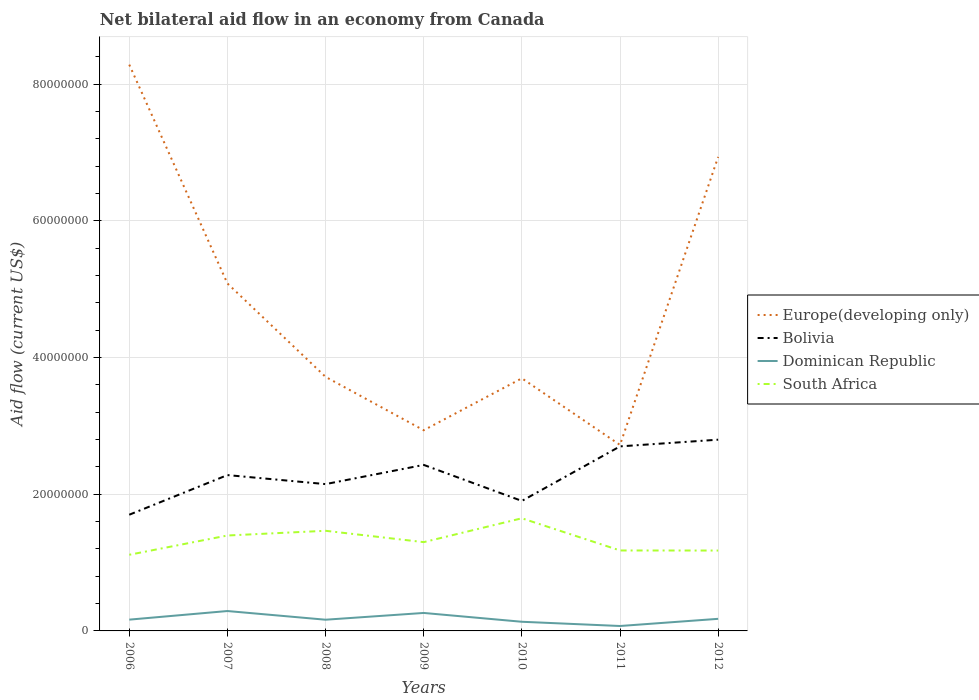Is the number of lines equal to the number of legend labels?
Your response must be concise. Yes. Across all years, what is the maximum net bilateral aid flow in South Africa?
Keep it short and to the point. 1.11e+07. What is the total net bilateral aid flow in Dominican Republic in the graph?
Provide a succinct answer. 1.14e+06. What is the difference between the highest and the second highest net bilateral aid flow in South Africa?
Provide a succinct answer. 5.34e+06. Is the net bilateral aid flow in Dominican Republic strictly greater than the net bilateral aid flow in Bolivia over the years?
Make the answer very short. Yes. How many years are there in the graph?
Offer a very short reply. 7. What is the difference between two consecutive major ticks on the Y-axis?
Keep it short and to the point. 2.00e+07. Does the graph contain any zero values?
Keep it short and to the point. No. Where does the legend appear in the graph?
Make the answer very short. Center right. How many legend labels are there?
Ensure brevity in your answer.  4. What is the title of the graph?
Give a very brief answer. Net bilateral aid flow in an economy from Canada. What is the Aid flow (current US$) in Europe(developing only) in 2006?
Keep it short and to the point. 8.28e+07. What is the Aid flow (current US$) in Bolivia in 2006?
Make the answer very short. 1.70e+07. What is the Aid flow (current US$) of Dominican Republic in 2006?
Your answer should be compact. 1.65e+06. What is the Aid flow (current US$) of South Africa in 2006?
Offer a very short reply. 1.11e+07. What is the Aid flow (current US$) in Europe(developing only) in 2007?
Make the answer very short. 5.08e+07. What is the Aid flow (current US$) in Bolivia in 2007?
Make the answer very short. 2.28e+07. What is the Aid flow (current US$) of Dominican Republic in 2007?
Your answer should be very brief. 2.91e+06. What is the Aid flow (current US$) in South Africa in 2007?
Your response must be concise. 1.40e+07. What is the Aid flow (current US$) of Europe(developing only) in 2008?
Your answer should be compact. 3.72e+07. What is the Aid flow (current US$) of Bolivia in 2008?
Offer a terse response. 2.15e+07. What is the Aid flow (current US$) in Dominican Republic in 2008?
Your response must be concise. 1.64e+06. What is the Aid flow (current US$) of South Africa in 2008?
Provide a short and direct response. 1.46e+07. What is the Aid flow (current US$) of Europe(developing only) in 2009?
Keep it short and to the point. 2.94e+07. What is the Aid flow (current US$) of Bolivia in 2009?
Keep it short and to the point. 2.43e+07. What is the Aid flow (current US$) in Dominican Republic in 2009?
Offer a terse response. 2.63e+06. What is the Aid flow (current US$) of South Africa in 2009?
Keep it short and to the point. 1.30e+07. What is the Aid flow (current US$) of Europe(developing only) in 2010?
Offer a terse response. 3.70e+07. What is the Aid flow (current US$) of Bolivia in 2010?
Offer a very short reply. 1.90e+07. What is the Aid flow (current US$) in Dominican Republic in 2010?
Offer a terse response. 1.34e+06. What is the Aid flow (current US$) of South Africa in 2010?
Keep it short and to the point. 1.65e+07. What is the Aid flow (current US$) in Europe(developing only) in 2011?
Keep it short and to the point. 2.72e+07. What is the Aid flow (current US$) of Bolivia in 2011?
Make the answer very short. 2.70e+07. What is the Aid flow (current US$) of Dominican Republic in 2011?
Give a very brief answer. 7.20e+05. What is the Aid flow (current US$) in South Africa in 2011?
Give a very brief answer. 1.18e+07. What is the Aid flow (current US$) in Europe(developing only) in 2012?
Your response must be concise. 6.94e+07. What is the Aid flow (current US$) of Bolivia in 2012?
Your response must be concise. 2.80e+07. What is the Aid flow (current US$) in Dominican Republic in 2012?
Keep it short and to the point. 1.77e+06. What is the Aid flow (current US$) in South Africa in 2012?
Offer a very short reply. 1.18e+07. Across all years, what is the maximum Aid flow (current US$) of Europe(developing only)?
Offer a very short reply. 8.28e+07. Across all years, what is the maximum Aid flow (current US$) in Bolivia?
Provide a succinct answer. 2.80e+07. Across all years, what is the maximum Aid flow (current US$) in Dominican Republic?
Offer a very short reply. 2.91e+06. Across all years, what is the maximum Aid flow (current US$) of South Africa?
Your answer should be compact. 1.65e+07. Across all years, what is the minimum Aid flow (current US$) of Europe(developing only)?
Your answer should be very brief. 2.72e+07. Across all years, what is the minimum Aid flow (current US$) in Bolivia?
Give a very brief answer. 1.70e+07. Across all years, what is the minimum Aid flow (current US$) in Dominican Republic?
Make the answer very short. 7.20e+05. Across all years, what is the minimum Aid flow (current US$) in South Africa?
Your answer should be compact. 1.11e+07. What is the total Aid flow (current US$) in Europe(developing only) in the graph?
Offer a very short reply. 3.34e+08. What is the total Aid flow (current US$) in Bolivia in the graph?
Provide a succinct answer. 1.60e+08. What is the total Aid flow (current US$) of Dominican Republic in the graph?
Give a very brief answer. 1.27e+07. What is the total Aid flow (current US$) in South Africa in the graph?
Ensure brevity in your answer.  9.28e+07. What is the difference between the Aid flow (current US$) in Europe(developing only) in 2006 and that in 2007?
Ensure brevity in your answer.  3.20e+07. What is the difference between the Aid flow (current US$) in Bolivia in 2006 and that in 2007?
Offer a terse response. -5.80e+06. What is the difference between the Aid flow (current US$) of Dominican Republic in 2006 and that in 2007?
Offer a very short reply. -1.26e+06. What is the difference between the Aid flow (current US$) of South Africa in 2006 and that in 2007?
Your response must be concise. -2.82e+06. What is the difference between the Aid flow (current US$) of Europe(developing only) in 2006 and that in 2008?
Your answer should be very brief. 4.57e+07. What is the difference between the Aid flow (current US$) of Bolivia in 2006 and that in 2008?
Offer a very short reply. -4.48e+06. What is the difference between the Aid flow (current US$) of South Africa in 2006 and that in 2008?
Give a very brief answer. -3.51e+06. What is the difference between the Aid flow (current US$) in Europe(developing only) in 2006 and that in 2009?
Offer a very short reply. 5.35e+07. What is the difference between the Aid flow (current US$) of Bolivia in 2006 and that in 2009?
Give a very brief answer. -7.29e+06. What is the difference between the Aid flow (current US$) of Dominican Republic in 2006 and that in 2009?
Provide a short and direct response. -9.80e+05. What is the difference between the Aid flow (current US$) in South Africa in 2006 and that in 2009?
Ensure brevity in your answer.  -1.85e+06. What is the difference between the Aid flow (current US$) of Europe(developing only) in 2006 and that in 2010?
Offer a terse response. 4.59e+07. What is the difference between the Aid flow (current US$) of Bolivia in 2006 and that in 2010?
Your answer should be very brief. -2.02e+06. What is the difference between the Aid flow (current US$) in South Africa in 2006 and that in 2010?
Give a very brief answer. -5.34e+06. What is the difference between the Aid flow (current US$) in Europe(developing only) in 2006 and that in 2011?
Offer a terse response. 5.56e+07. What is the difference between the Aid flow (current US$) of Bolivia in 2006 and that in 2011?
Provide a short and direct response. -1.00e+07. What is the difference between the Aid flow (current US$) of Dominican Republic in 2006 and that in 2011?
Your answer should be very brief. 9.30e+05. What is the difference between the Aid flow (current US$) of South Africa in 2006 and that in 2011?
Offer a terse response. -6.30e+05. What is the difference between the Aid flow (current US$) in Europe(developing only) in 2006 and that in 2012?
Give a very brief answer. 1.35e+07. What is the difference between the Aid flow (current US$) in Bolivia in 2006 and that in 2012?
Keep it short and to the point. -1.10e+07. What is the difference between the Aid flow (current US$) of Dominican Republic in 2006 and that in 2012?
Ensure brevity in your answer.  -1.20e+05. What is the difference between the Aid flow (current US$) in South Africa in 2006 and that in 2012?
Ensure brevity in your answer.  -6.20e+05. What is the difference between the Aid flow (current US$) in Europe(developing only) in 2007 and that in 2008?
Provide a short and direct response. 1.37e+07. What is the difference between the Aid flow (current US$) in Bolivia in 2007 and that in 2008?
Provide a short and direct response. 1.32e+06. What is the difference between the Aid flow (current US$) in Dominican Republic in 2007 and that in 2008?
Your response must be concise. 1.27e+06. What is the difference between the Aid flow (current US$) of South Africa in 2007 and that in 2008?
Keep it short and to the point. -6.90e+05. What is the difference between the Aid flow (current US$) in Europe(developing only) in 2007 and that in 2009?
Ensure brevity in your answer.  2.15e+07. What is the difference between the Aid flow (current US$) in Bolivia in 2007 and that in 2009?
Offer a terse response. -1.49e+06. What is the difference between the Aid flow (current US$) of Dominican Republic in 2007 and that in 2009?
Offer a very short reply. 2.80e+05. What is the difference between the Aid flow (current US$) of South Africa in 2007 and that in 2009?
Your answer should be compact. 9.70e+05. What is the difference between the Aid flow (current US$) of Europe(developing only) in 2007 and that in 2010?
Make the answer very short. 1.39e+07. What is the difference between the Aid flow (current US$) in Bolivia in 2007 and that in 2010?
Make the answer very short. 3.78e+06. What is the difference between the Aid flow (current US$) of Dominican Republic in 2007 and that in 2010?
Your answer should be very brief. 1.57e+06. What is the difference between the Aid flow (current US$) of South Africa in 2007 and that in 2010?
Offer a very short reply. -2.52e+06. What is the difference between the Aid flow (current US$) in Europe(developing only) in 2007 and that in 2011?
Provide a short and direct response. 2.36e+07. What is the difference between the Aid flow (current US$) in Bolivia in 2007 and that in 2011?
Make the answer very short. -4.20e+06. What is the difference between the Aid flow (current US$) of Dominican Republic in 2007 and that in 2011?
Your answer should be very brief. 2.19e+06. What is the difference between the Aid flow (current US$) of South Africa in 2007 and that in 2011?
Offer a very short reply. 2.19e+06. What is the difference between the Aid flow (current US$) of Europe(developing only) in 2007 and that in 2012?
Make the answer very short. -1.85e+07. What is the difference between the Aid flow (current US$) in Bolivia in 2007 and that in 2012?
Offer a terse response. -5.18e+06. What is the difference between the Aid flow (current US$) in Dominican Republic in 2007 and that in 2012?
Your response must be concise. 1.14e+06. What is the difference between the Aid flow (current US$) of South Africa in 2007 and that in 2012?
Your answer should be very brief. 2.20e+06. What is the difference between the Aid flow (current US$) in Europe(developing only) in 2008 and that in 2009?
Ensure brevity in your answer.  7.81e+06. What is the difference between the Aid flow (current US$) of Bolivia in 2008 and that in 2009?
Ensure brevity in your answer.  -2.81e+06. What is the difference between the Aid flow (current US$) of Dominican Republic in 2008 and that in 2009?
Make the answer very short. -9.90e+05. What is the difference between the Aid flow (current US$) in South Africa in 2008 and that in 2009?
Your answer should be very brief. 1.66e+06. What is the difference between the Aid flow (current US$) of Bolivia in 2008 and that in 2010?
Offer a terse response. 2.46e+06. What is the difference between the Aid flow (current US$) in South Africa in 2008 and that in 2010?
Give a very brief answer. -1.83e+06. What is the difference between the Aid flow (current US$) in Europe(developing only) in 2008 and that in 2011?
Offer a very short reply. 9.96e+06. What is the difference between the Aid flow (current US$) in Bolivia in 2008 and that in 2011?
Give a very brief answer. -5.52e+06. What is the difference between the Aid flow (current US$) of Dominican Republic in 2008 and that in 2011?
Make the answer very short. 9.20e+05. What is the difference between the Aid flow (current US$) of South Africa in 2008 and that in 2011?
Make the answer very short. 2.88e+06. What is the difference between the Aid flow (current US$) in Europe(developing only) in 2008 and that in 2012?
Keep it short and to the point. -3.22e+07. What is the difference between the Aid flow (current US$) in Bolivia in 2008 and that in 2012?
Offer a terse response. -6.50e+06. What is the difference between the Aid flow (current US$) in Dominican Republic in 2008 and that in 2012?
Offer a very short reply. -1.30e+05. What is the difference between the Aid flow (current US$) of South Africa in 2008 and that in 2012?
Your answer should be very brief. 2.89e+06. What is the difference between the Aid flow (current US$) of Europe(developing only) in 2009 and that in 2010?
Provide a short and direct response. -7.60e+06. What is the difference between the Aid flow (current US$) of Bolivia in 2009 and that in 2010?
Offer a very short reply. 5.27e+06. What is the difference between the Aid flow (current US$) in Dominican Republic in 2009 and that in 2010?
Your response must be concise. 1.29e+06. What is the difference between the Aid flow (current US$) in South Africa in 2009 and that in 2010?
Give a very brief answer. -3.49e+06. What is the difference between the Aid flow (current US$) of Europe(developing only) in 2009 and that in 2011?
Provide a succinct answer. 2.15e+06. What is the difference between the Aid flow (current US$) of Bolivia in 2009 and that in 2011?
Ensure brevity in your answer.  -2.71e+06. What is the difference between the Aid flow (current US$) in Dominican Republic in 2009 and that in 2011?
Your answer should be compact. 1.91e+06. What is the difference between the Aid flow (current US$) of South Africa in 2009 and that in 2011?
Ensure brevity in your answer.  1.22e+06. What is the difference between the Aid flow (current US$) in Europe(developing only) in 2009 and that in 2012?
Offer a terse response. -4.00e+07. What is the difference between the Aid flow (current US$) of Bolivia in 2009 and that in 2012?
Your answer should be very brief. -3.69e+06. What is the difference between the Aid flow (current US$) in Dominican Republic in 2009 and that in 2012?
Ensure brevity in your answer.  8.60e+05. What is the difference between the Aid flow (current US$) in South Africa in 2009 and that in 2012?
Make the answer very short. 1.23e+06. What is the difference between the Aid flow (current US$) in Europe(developing only) in 2010 and that in 2011?
Keep it short and to the point. 9.75e+06. What is the difference between the Aid flow (current US$) of Bolivia in 2010 and that in 2011?
Provide a succinct answer. -7.98e+06. What is the difference between the Aid flow (current US$) of Dominican Republic in 2010 and that in 2011?
Keep it short and to the point. 6.20e+05. What is the difference between the Aid flow (current US$) in South Africa in 2010 and that in 2011?
Give a very brief answer. 4.71e+06. What is the difference between the Aid flow (current US$) in Europe(developing only) in 2010 and that in 2012?
Your answer should be very brief. -3.24e+07. What is the difference between the Aid flow (current US$) in Bolivia in 2010 and that in 2012?
Keep it short and to the point. -8.96e+06. What is the difference between the Aid flow (current US$) of Dominican Republic in 2010 and that in 2012?
Provide a succinct answer. -4.30e+05. What is the difference between the Aid flow (current US$) in South Africa in 2010 and that in 2012?
Your answer should be very brief. 4.72e+06. What is the difference between the Aid flow (current US$) in Europe(developing only) in 2011 and that in 2012?
Your answer should be compact. -4.21e+07. What is the difference between the Aid flow (current US$) in Bolivia in 2011 and that in 2012?
Make the answer very short. -9.80e+05. What is the difference between the Aid flow (current US$) of Dominican Republic in 2011 and that in 2012?
Provide a succinct answer. -1.05e+06. What is the difference between the Aid flow (current US$) of Europe(developing only) in 2006 and the Aid flow (current US$) of Bolivia in 2007?
Your answer should be compact. 6.00e+07. What is the difference between the Aid flow (current US$) in Europe(developing only) in 2006 and the Aid flow (current US$) in Dominican Republic in 2007?
Your answer should be compact. 7.99e+07. What is the difference between the Aid flow (current US$) in Europe(developing only) in 2006 and the Aid flow (current US$) in South Africa in 2007?
Make the answer very short. 6.89e+07. What is the difference between the Aid flow (current US$) of Bolivia in 2006 and the Aid flow (current US$) of Dominican Republic in 2007?
Your answer should be very brief. 1.41e+07. What is the difference between the Aid flow (current US$) in Bolivia in 2006 and the Aid flow (current US$) in South Africa in 2007?
Offer a terse response. 3.04e+06. What is the difference between the Aid flow (current US$) in Dominican Republic in 2006 and the Aid flow (current US$) in South Africa in 2007?
Make the answer very short. -1.23e+07. What is the difference between the Aid flow (current US$) of Europe(developing only) in 2006 and the Aid flow (current US$) of Bolivia in 2008?
Provide a succinct answer. 6.14e+07. What is the difference between the Aid flow (current US$) in Europe(developing only) in 2006 and the Aid flow (current US$) in Dominican Republic in 2008?
Give a very brief answer. 8.12e+07. What is the difference between the Aid flow (current US$) in Europe(developing only) in 2006 and the Aid flow (current US$) in South Africa in 2008?
Keep it short and to the point. 6.82e+07. What is the difference between the Aid flow (current US$) of Bolivia in 2006 and the Aid flow (current US$) of Dominican Republic in 2008?
Your response must be concise. 1.54e+07. What is the difference between the Aid flow (current US$) of Bolivia in 2006 and the Aid flow (current US$) of South Africa in 2008?
Provide a succinct answer. 2.35e+06. What is the difference between the Aid flow (current US$) in Dominican Republic in 2006 and the Aid flow (current US$) in South Africa in 2008?
Give a very brief answer. -1.30e+07. What is the difference between the Aid flow (current US$) of Europe(developing only) in 2006 and the Aid flow (current US$) of Bolivia in 2009?
Offer a very short reply. 5.86e+07. What is the difference between the Aid flow (current US$) of Europe(developing only) in 2006 and the Aid flow (current US$) of Dominican Republic in 2009?
Provide a succinct answer. 8.02e+07. What is the difference between the Aid flow (current US$) in Europe(developing only) in 2006 and the Aid flow (current US$) in South Africa in 2009?
Your answer should be very brief. 6.99e+07. What is the difference between the Aid flow (current US$) of Bolivia in 2006 and the Aid flow (current US$) of Dominican Republic in 2009?
Offer a terse response. 1.44e+07. What is the difference between the Aid flow (current US$) of Bolivia in 2006 and the Aid flow (current US$) of South Africa in 2009?
Provide a succinct answer. 4.01e+06. What is the difference between the Aid flow (current US$) in Dominican Republic in 2006 and the Aid flow (current US$) in South Africa in 2009?
Ensure brevity in your answer.  -1.13e+07. What is the difference between the Aid flow (current US$) of Europe(developing only) in 2006 and the Aid flow (current US$) of Bolivia in 2010?
Your response must be concise. 6.38e+07. What is the difference between the Aid flow (current US$) of Europe(developing only) in 2006 and the Aid flow (current US$) of Dominican Republic in 2010?
Your response must be concise. 8.15e+07. What is the difference between the Aid flow (current US$) in Europe(developing only) in 2006 and the Aid flow (current US$) in South Africa in 2010?
Offer a very short reply. 6.64e+07. What is the difference between the Aid flow (current US$) of Bolivia in 2006 and the Aid flow (current US$) of Dominican Republic in 2010?
Your answer should be compact. 1.57e+07. What is the difference between the Aid flow (current US$) of Bolivia in 2006 and the Aid flow (current US$) of South Africa in 2010?
Provide a succinct answer. 5.20e+05. What is the difference between the Aid flow (current US$) in Dominican Republic in 2006 and the Aid flow (current US$) in South Africa in 2010?
Your answer should be very brief. -1.48e+07. What is the difference between the Aid flow (current US$) of Europe(developing only) in 2006 and the Aid flow (current US$) of Bolivia in 2011?
Your answer should be very brief. 5.58e+07. What is the difference between the Aid flow (current US$) of Europe(developing only) in 2006 and the Aid flow (current US$) of Dominican Republic in 2011?
Give a very brief answer. 8.21e+07. What is the difference between the Aid flow (current US$) of Europe(developing only) in 2006 and the Aid flow (current US$) of South Africa in 2011?
Keep it short and to the point. 7.11e+07. What is the difference between the Aid flow (current US$) of Bolivia in 2006 and the Aid flow (current US$) of Dominican Republic in 2011?
Your answer should be very brief. 1.63e+07. What is the difference between the Aid flow (current US$) in Bolivia in 2006 and the Aid flow (current US$) in South Africa in 2011?
Offer a terse response. 5.23e+06. What is the difference between the Aid flow (current US$) of Dominican Republic in 2006 and the Aid flow (current US$) of South Africa in 2011?
Provide a short and direct response. -1.01e+07. What is the difference between the Aid flow (current US$) in Europe(developing only) in 2006 and the Aid flow (current US$) in Bolivia in 2012?
Provide a short and direct response. 5.49e+07. What is the difference between the Aid flow (current US$) in Europe(developing only) in 2006 and the Aid flow (current US$) in Dominican Republic in 2012?
Your response must be concise. 8.11e+07. What is the difference between the Aid flow (current US$) in Europe(developing only) in 2006 and the Aid flow (current US$) in South Africa in 2012?
Ensure brevity in your answer.  7.11e+07. What is the difference between the Aid flow (current US$) of Bolivia in 2006 and the Aid flow (current US$) of Dominican Republic in 2012?
Make the answer very short. 1.52e+07. What is the difference between the Aid flow (current US$) of Bolivia in 2006 and the Aid flow (current US$) of South Africa in 2012?
Offer a very short reply. 5.24e+06. What is the difference between the Aid flow (current US$) in Dominican Republic in 2006 and the Aid flow (current US$) in South Africa in 2012?
Your answer should be very brief. -1.01e+07. What is the difference between the Aid flow (current US$) in Europe(developing only) in 2007 and the Aid flow (current US$) in Bolivia in 2008?
Your answer should be very brief. 2.94e+07. What is the difference between the Aid flow (current US$) in Europe(developing only) in 2007 and the Aid flow (current US$) in Dominican Republic in 2008?
Your response must be concise. 4.92e+07. What is the difference between the Aid flow (current US$) in Europe(developing only) in 2007 and the Aid flow (current US$) in South Africa in 2008?
Offer a very short reply. 3.62e+07. What is the difference between the Aid flow (current US$) in Bolivia in 2007 and the Aid flow (current US$) in Dominican Republic in 2008?
Offer a terse response. 2.12e+07. What is the difference between the Aid flow (current US$) in Bolivia in 2007 and the Aid flow (current US$) in South Africa in 2008?
Offer a terse response. 8.15e+06. What is the difference between the Aid flow (current US$) in Dominican Republic in 2007 and the Aid flow (current US$) in South Africa in 2008?
Keep it short and to the point. -1.17e+07. What is the difference between the Aid flow (current US$) of Europe(developing only) in 2007 and the Aid flow (current US$) of Bolivia in 2009?
Offer a very short reply. 2.66e+07. What is the difference between the Aid flow (current US$) of Europe(developing only) in 2007 and the Aid flow (current US$) of Dominican Republic in 2009?
Offer a very short reply. 4.82e+07. What is the difference between the Aid flow (current US$) in Europe(developing only) in 2007 and the Aid flow (current US$) in South Africa in 2009?
Your answer should be very brief. 3.78e+07. What is the difference between the Aid flow (current US$) of Bolivia in 2007 and the Aid flow (current US$) of Dominican Republic in 2009?
Offer a terse response. 2.02e+07. What is the difference between the Aid flow (current US$) of Bolivia in 2007 and the Aid flow (current US$) of South Africa in 2009?
Give a very brief answer. 9.81e+06. What is the difference between the Aid flow (current US$) in Dominican Republic in 2007 and the Aid flow (current US$) in South Africa in 2009?
Keep it short and to the point. -1.01e+07. What is the difference between the Aid flow (current US$) in Europe(developing only) in 2007 and the Aid flow (current US$) in Bolivia in 2010?
Provide a short and direct response. 3.18e+07. What is the difference between the Aid flow (current US$) in Europe(developing only) in 2007 and the Aid flow (current US$) in Dominican Republic in 2010?
Your answer should be very brief. 4.95e+07. What is the difference between the Aid flow (current US$) in Europe(developing only) in 2007 and the Aid flow (current US$) in South Africa in 2010?
Your answer should be compact. 3.44e+07. What is the difference between the Aid flow (current US$) in Bolivia in 2007 and the Aid flow (current US$) in Dominican Republic in 2010?
Your answer should be very brief. 2.15e+07. What is the difference between the Aid flow (current US$) in Bolivia in 2007 and the Aid flow (current US$) in South Africa in 2010?
Keep it short and to the point. 6.32e+06. What is the difference between the Aid flow (current US$) in Dominican Republic in 2007 and the Aid flow (current US$) in South Africa in 2010?
Your response must be concise. -1.36e+07. What is the difference between the Aid flow (current US$) in Europe(developing only) in 2007 and the Aid flow (current US$) in Bolivia in 2011?
Provide a succinct answer. 2.38e+07. What is the difference between the Aid flow (current US$) in Europe(developing only) in 2007 and the Aid flow (current US$) in Dominican Republic in 2011?
Make the answer very short. 5.01e+07. What is the difference between the Aid flow (current US$) of Europe(developing only) in 2007 and the Aid flow (current US$) of South Africa in 2011?
Give a very brief answer. 3.91e+07. What is the difference between the Aid flow (current US$) of Bolivia in 2007 and the Aid flow (current US$) of Dominican Republic in 2011?
Offer a terse response. 2.21e+07. What is the difference between the Aid flow (current US$) in Bolivia in 2007 and the Aid flow (current US$) in South Africa in 2011?
Ensure brevity in your answer.  1.10e+07. What is the difference between the Aid flow (current US$) of Dominican Republic in 2007 and the Aid flow (current US$) of South Africa in 2011?
Provide a succinct answer. -8.86e+06. What is the difference between the Aid flow (current US$) in Europe(developing only) in 2007 and the Aid flow (current US$) in Bolivia in 2012?
Make the answer very short. 2.29e+07. What is the difference between the Aid flow (current US$) of Europe(developing only) in 2007 and the Aid flow (current US$) of Dominican Republic in 2012?
Your answer should be compact. 4.91e+07. What is the difference between the Aid flow (current US$) in Europe(developing only) in 2007 and the Aid flow (current US$) in South Africa in 2012?
Make the answer very short. 3.91e+07. What is the difference between the Aid flow (current US$) in Bolivia in 2007 and the Aid flow (current US$) in Dominican Republic in 2012?
Ensure brevity in your answer.  2.10e+07. What is the difference between the Aid flow (current US$) of Bolivia in 2007 and the Aid flow (current US$) of South Africa in 2012?
Ensure brevity in your answer.  1.10e+07. What is the difference between the Aid flow (current US$) of Dominican Republic in 2007 and the Aid flow (current US$) of South Africa in 2012?
Offer a very short reply. -8.85e+06. What is the difference between the Aid flow (current US$) of Europe(developing only) in 2008 and the Aid flow (current US$) of Bolivia in 2009?
Offer a very short reply. 1.29e+07. What is the difference between the Aid flow (current US$) in Europe(developing only) in 2008 and the Aid flow (current US$) in Dominican Republic in 2009?
Offer a very short reply. 3.45e+07. What is the difference between the Aid flow (current US$) in Europe(developing only) in 2008 and the Aid flow (current US$) in South Africa in 2009?
Provide a short and direct response. 2.42e+07. What is the difference between the Aid flow (current US$) in Bolivia in 2008 and the Aid flow (current US$) in Dominican Republic in 2009?
Provide a succinct answer. 1.88e+07. What is the difference between the Aid flow (current US$) in Bolivia in 2008 and the Aid flow (current US$) in South Africa in 2009?
Provide a succinct answer. 8.49e+06. What is the difference between the Aid flow (current US$) in Dominican Republic in 2008 and the Aid flow (current US$) in South Africa in 2009?
Ensure brevity in your answer.  -1.14e+07. What is the difference between the Aid flow (current US$) of Europe(developing only) in 2008 and the Aid flow (current US$) of Bolivia in 2010?
Keep it short and to the point. 1.82e+07. What is the difference between the Aid flow (current US$) of Europe(developing only) in 2008 and the Aid flow (current US$) of Dominican Republic in 2010?
Your response must be concise. 3.58e+07. What is the difference between the Aid flow (current US$) in Europe(developing only) in 2008 and the Aid flow (current US$) in South Africa in 2010?
Offer a very short reply. 2.07e+07. What is the difference between the Aid flow (current US$) in Bolivia in 2008 and the Aid flow (current US$) in Dominican Republic in 2010?
Your answer should be compact. 2.01e+07. What is the difference between the Aid flow (current US$) of Bolivia in 2008 and the Aid flow (current US$) of South Africa in 2010?
Provide a succinct answer. 5.00e+06. What is the difference between the Aid flow (current US$) in Dominican Republic in 2008 and the Aid flow (current US$) in South Africa in 2010?
Your response must be concise. -1.48e+07. What is the difference between the Aid flow (current US$) in Europe(developing only) in 2008 and the Aid flow (current US$) in Bolivia in 2011?
Provide a succinct answer. 1.02e+07. What is the difference between the Aid flow (current US$) of Europe(developing only) in 2008 and the Aid flow (current US$) of Dominican Republic in 2011?
Offer a very short reply. 3.64e+07. What is the difference between the Aid flow (current US$) in Europe(developing only) in 2008 and the Aid flow (current US$) in South Africa in 2011?
Your response must be concise. 2.54e+07. What is the difference between the Aid flow (current US$) of Bolivia in 2008 and the Aid flow (current US$) of Dominican Republic in 2011?
Make the answer very short. 2.08e+07. What is the difference between the Aid flow (current US$) of Bolivia in 2008 and the Aid flow (current US$) of South Africa in 2011?
Make the answer very short. 9.71e+06. What is the difference between the Aid flow (current US$) in Dominican Republic in 2008 and the Aid flow (current US$) in South Africa in 2011?
Offer a very short reply. -1.01e+07. What is the difference between the Aid flow (current US$) of Europe(developing only) in 2008 and the Aid flow (current US$) of Bolivia in 2012?
Give a very brief answer. 9.19e+06. What is the difference between the Aid flow (current US$) in Europe(developing only) in 2008 and the Aid flow (current US$) in Dominican Republic in 2012?
Offer a terse response. 3.54e+07. What is the difference between the Aid flow (current US$) in Europe(developing only) in 2008 and the Aid flow (current US$) in South Africa in 2012?
Offer a very short reply. 2.54e+07. What is the difference between the Aid flow (current US$) of Bolivia in 2008 and the Aid flow (current US$) of Dominican Republic in 2012?
Provide a short and direct response. 1.97e+07. What is the difference between the Aid flow (current US$) in Bolivia in 2008 and the Aid flow (current US$) in South Africa in 2012?
Your answer should be very brief. 9.72e+06. What is the difference between the Aid flow (current US$) of Dominican Republic in 2008 and the Aid flow (current US$) of South Africa in 2012?
Provide a succinct answer. -1.01e+07. What is the difference between the Aid flow (current US$) of Europe(developing only) in 2009 and the Aid flow (current US$) of Bolivia in 2010?
Provide a succinct answer. 1.03e+07. What is the difference between the Aid flow (current US$) of Europe(developing only) in 2009 and the Aid flow (current US$) of Dominican Republic in 2010?
Your response must be concise. 2.80e+07. What is the difference between the Aid flow (current US$) in Europe(developing only) in 2009 and the Aid flow (current US$) in South Africa in 2010?
Provide a short and direct response. 1.29e+07. What is the difference between the Aid flow (current US$) of Bolivia in 2009 and the Aid flow (current US$) of Dominican Republic in 2010?
Provide a succinct answer. 2.30e+07. What is the difference between the Aid flow (current US$) of Bolivia in 2009 and the Aid flow (current US$) of South Africa in 2010?
Provide a succinct answer. 7.81e+06. What is the difference between the Aid flow (current US$) in Dominican Republic in 2009 and the Aid flow (current US$) in South Africa in 2010?
Make the answer very short. -1.38e+07. What is the difference between the Aid flow (current US$) in Europe(developing only) in 2009 and the Aid flow (current US$) in Bolivia in 2011?
Provide a short and direct response. 2.36e+06. What is the difference between the Aid flow (current US$) in Europe(developing only) in 2009 and the Aid flow (current US$) in Dominican Republic in 2011?
Give a very brief answer. 2.86e+07. What is the difference between the Aid flow (current US$) in Europe(developing only) in 2009 and the Aid flow (current US$) in South Africa in 2011?
Keep it short and to the point. 1.76e+07. What is the difference between the Aid flow (current US$) in Bolivia in 2009 and the Aid flow (current US$) in Dominican Republic in 2011?
Ensure brevity in your answer.  2.36e+07. What is the difference between the Aid flow (current US$) of Bolivia in 2009 and the Aid flow (current US$) of South Africa in 2011?
Your answer should be very brief. 1.25e+07. What is the difference between the Aid flow (current US$) in Dominican Republic in 2009 and the Aid flow (current US$) in South Africa in 2011?
Your answer should be very brief. -9.14e+06. What is the difference between the Aid flow (current US$) in Europe(developing only) in 2009 and the Aid flow (current US$) in Bolivia in 2012?
Keep it short and to the point. 1.38e+06. What is the difference between the Aid flow (current US$) of Europe(developing only) in 2009 and the Aid flow (current US$) of Dominican Republic in 2012?
Your answer should be very brief. 2.76e+07. What is the difference between the Aid flow (current US$) in Europe(developing only) in 2009 and the Aid flow (current US$) in South Africa in 2012?
Provide a succinct answer. 1.76e+07. What is the difference between the Aid flow (current US$) of Bolivia in 2009 and the Aid flow (current US$) of Dominican Republic in 2012?
Ensure brevity in your answer.  2.25e+07. What is the difference between the Aid flow (current US$) in Bolivia in 2009 and the Aid flow (current US$) in South Africa in 2012?
Offer a very short reply. 1.25e+07. What is the difference between the Aid flow (current US$) in Dominican Republic in 2009 and the Aid flow (current US$) in South Africa in 2012?
Ensure brevity in your answer.  -9.13e+06. What is the difference between the Aid flow (current US$) of Europe(developing only) in 2010 and the Aid flow (current US$) of Bolivia in 2011?
Offer a terse response. 9.96e+06. What is the difference between the Aid flow (current US$) in Europe(developing only) in 2010 and the Aid flow (current US$) in Dominican Republic in 2011?
Your answer should be compact. 3.62e+07. What is the difference between the Aid flow (current US$) of Europe(developing only) in 2010 and the Aid flow (current US$) of South Africa in 2011?
Give a very brief answer. 2.52e+07. What is the difference between the Aid flow (current US$) in Bolivia in 2010 and the Aid flow (current US$) in Dominican Republic in 2011?
Offer a terse response. 1.83e+07. What is the difference between the Aid flow (current US$) of Bolivia in 2010 and the Aid flow (current US$) of South Africa in 2011?
Offer a very short reply. 7.25e+06. What is the difference between the Aid flow (current US$) in Dominican Republic in 2010 and the Aid flow (current US$) in South Africa in 2011?
Your answer should be compact. -1.04e+07. What is the difference between the Aid flow (current US$) in Europe(developing only) in 2010 and the Aid flow (current US$) in Bolivia in 2012?
Keep it short and to the point. 8.98e+06. What is the difference between the Aid flow (current US$) in Europe(developing only) in 2010 and the Aid flow (current US$) in Dominican Republic in 2012?
Your response must be concise. 3.52e+07. What is the difference between the Aid flow (current US$) in Europe(developing only) in 2010 and the Aid flow (current US$) in South Africa in 2012?
Offer a very short reply. 2.52e+07. What is the difference between the Aid flow (current US$) in Bolivia in 2010 and the Aid flow (current US$) in Dominican Republic in 2012?
Make the answer very short. 1.72e+07. What is the difference between the Aid flow (current US$) of Bolivia in 2010 and the Aid flow (current US$) of South Africa in 2012?
Your answer should be compact. 7.26e+06. What is the difference between the Aid flow (current US$) in Dominican Republic in 2010 and the Aid flow (current US$) in South Africa in 2012?
Provide a succinct answer. -1.04e+07. What is the difference between the Aid flow (current US$) of Europe(developing only) in 2011 and the Aid flow (current US$) of Bolivia in 2012?
Offer a terse response. -7.70e+05. What is the difference between the Aid flow (current US$) in Europe(developing only) in 2011 and the Aid flow (current US$) in Dominican Republic in 2012?
Your answer should be compact. 2.54e+07. What is the difference between the Aid flow (current US$) of Europe(developing only) in 2011 and the Aid flow (current US$) of South Africa in 2012?
Your answer should be very brief. 1.54e+07. What is the difference between the Aid flow (current US$) in Bolivia in 2011 and the Aid flow (current US$) in Dominican Republic in 2012?
Your response must be concise. 2.52e+07. What is the difference between the Aid flow (current US$) in Bolivia in 2011 and the Aid flow (current US$) in South Africa in 2012?
Provide a short and direct response. 1.52e+07. What is the difference between the Aid flow (current US$) in Dominican Republic in 2011 and the Aid flow (current US$) in South Africa in 2012?
Your response must be concise. -1.10e+07. What is the average Aid flow (current US$) in Europe(developing only) per year?
Offer a very short reply. 4.77e+07. What is the average Aid flow (current US$) in Bolivia per year?
Provide a short and direct response. 2.28e+07. What is the average Aid flow (current US$) in Dominican Republic per year?
Offer a very short reply. 1.81e+06. What is the average Aid flow (current US$) of South Africa per year?
Offer a terse response. 1.32e+07. In the year 2006, what is the difference between the Aid flow (current US$) of Europe(developing only) and Aid flow (current US$) of Bolivia?
Provide a short and direct response. 6.58e+07. In the year 2006, what is the difference between the Aid flow (current US$) of Europe(developing only) and Aid flow (current US$) of Dominican Republic?
Offer a terse response. 8.12e+07. In the year 2006, what is the difference between the Aid flow (current US$) in Europe(developing only) and Aid flow (current US$) in South Africa?
Give a very brief answer. 7.17e+07. In the year 2006, what is the difference between the Aid flow (current US$) of Bolivia and Aid flow (current US$) of Dominican Republic?
Your answer should be compact. 1.54e+07. In the year 2006, what is the difference between the Aid flow (current US$) in Bolivia and Aid flow (current US$) in South Africa?
Make the answer very short. 5.86e+06. In the year 2006, what is the difference between the Aid flow (current US$) in Dominican Republic and Aid flow (current US$) in South Africa?
Offer a very short reply. -9.49e+06. In the year 2007, what is the difference between the Aid flow (current US$) of Europe(developing only) and Aid flow (current US$) of Bolivia?
Provide a short and direct response. 2.80e+07. In the year 2007, what is the difference between the Aid flow (current US$) of Europe(developing only) and Aid flow (current US$) of Dominican Republic?
Provide a succinct answer. 4.79e+07. In the year 2007, what is the difference between the Aid flow (current US$) in Europe(developing only) and Aid flow (current US$) in South Africa?
Keep it short and to the point. 3.69e+07. In the year 2007, what is the difference between the Aid flow (current US$) of Bolivia and Aid flow (current US$) of Dominican Republic?
Ensure brevity in your answer.  1.99e+07. In the year 2007, what is the difference between the Aid flow (current US$) in Bolivia and Aid flow (current US$) in South Africa?
Make the answer very short. 8.84e+06. In the year 2007, what is the difference between the Aid flow (current US$) in Dominican Republic and Aid flow (current US$) in South Africa?
Keep it short and to the point. -1.10e+07. In the year 2008, what is the difference between the Aid flow (current US$) of Europe(developing only) and Aid flow (current US$) of Bolivia?
Your answer should be very brief. 1.57e+07. In the year 2008, what is the difference between the Aid flow (current US$) in Europe(developing only) and Aid flow (current US$) in Dominican Republic?
Your response must be concise. 3.55e+07. In the year 2008, what is the difference between the Aid flow (current US$) of Europe(developing only) and Aid flow (current US$) of South Africa?
Your answer should be compact. 2.25e+07. In the year 2008, what is the difference between the Aid flow (current US$) of Bolivia and Aid flow (current US$) of Dominican Republic?
Provide a succinct answer. 1.98e+07. In the year 2008, what is the difference between the Aid flow (current US$) in Bolivia and Aid flow (current US$) in South Africa?
Offer a very short reply. 6.83e+06. In the year 2008, what is the difference between the Aid flow (current US$) of Dominican Republic and Aid flow (current US$) of South Africa?
Offer a terse response. -1.30e+07. In the year 2009, what is the difference between the Aid flow (current US$) in Europe(developing only) and Aid flow (current US$) in Bolivia?
Make the answer very short. 5.07e+06. In the year 2009, what is the difference between the Aid flow (current US$) in Europe(developing only) and Aid flow (current US$) in Dominican Republic?
Ensure brevity in your answer.  2.67e+07. In the year 2009, what is the difference between the Aid flow (current US$) in Europe(developing only) and Aid flow (current US$) in South Africa?
Your answer should be very brief. 1.64e+07. In the year 2009, what is the difference between the Aid flow (current US$) in Bolivia and Aid flow (current US$) in Dominican Republic?
Ensure brevity in your answer.  2.17e+07. In the year 2009, what is the difference between the Aid flow (current US$) of Bolivia and Aid flow (current US$) of South Africa?
Offer a very short reply. 1.13e+07. In the year 2009, what is the difference between the Aid flow (current US$) in Dominican Republic and Aid flow (current US$) in South Africa?
Keep it short and to the point. -1.04e+07. In the year 2010, what is the difference between the Aid flow (current US$) of Europe(developing only) and Aid flow (current US$) of Bolivia?
Keep it short and to the point. 1.79e+07. In the year 2010, what is the difference between the Aid flow (current US$) of Europe(developing only) and Aid flow (current US$) of Dominican Republic?
Your answer should be compact. 3.56e+07. In the year 2010, what is the difference between the Aid flow (current US$) of Europe(developing only) and Aid flow (current US$) of South Africa?
Make the answer very short. 2.05e+07. In the year 2010, what is the difference between the Aid flow (current US$) of Bolivia and Aid flow (current US$) of Dominican Republic?
Give a very brief answer. 1.77e+07. In the year 2010, what is the difference between the Aid flow (current US$) in Bolivia and Aid flow (current US$) in South Africa?
Keep it short and to the point. 2.54e+06. In the year 2010, what is the difference between the Aid flow (current US$) in Dominican Republic and Aid flow (current US$) in South Africa?
Provide a succinct answer. -1.51e+07. In the year 2011, what is the difference between the Aid flow (current US$) in Europe(developing only) and Aid flow (current US$) in Bolivia?
Keep it short and to the point. 2.10e+05. In the year 2011, what is the difference between the Aid flow (current US$) in Europe(developing only) and Aid flow (current US$) in Dominican Republic?
Offer a terse response. 2.65e+07. In the year 2011, what is the difference between the Aid flow (current US$) of Europe(developing only) and Aid flow (current US$) of South Africa?
Ensure brevity in your answer.  1.54e+07. In the year 2011, what is the difference between the Aid flow (current US$) of Bolivia and Aid flow (current US$) of Dominican Republic?
Keep it short and to the point. 2.63e+07. In the year 2011, what is the difference between the Aid flow (current US$) of Bolivia and Aid flow (current US$) of South Africa?
Make the answer very short. 1.52e+07. In the year 2011, what is the difference between the Aid flow (current US$) of Dominican Republic and Aid flow (current US$) of South Africa?
Make the answer very short. -1.10e+07. In the year 2012, what is the difference between the Aid flow (current US$) of Europe(developing only) and Aid flow (current US$) of Bolivia?
Keep it short and to the point. 4.14e+07. In the year 2012, what is the difference between the Aid flow (current US$) in Europe(developing only) and Aid flow (current US$) in Dominican Republic?
Give a very brief answer. 6.76e+07. In the year 2012, what is the difference between the Aid flow (current US$) of Europe(developing only) and Aid flow (current US$) of South Africa?
Give a very brief answer. 5.76e+07. In the year 2012, what is the difference between the Aid flow (current US$) in Bolivia and Aid flow (current US$) in Dominican Republic?
Make the answer very short. 2.62e+07. In the year 2012, what is the difference between the Aid flow (current US$) in Bolivia and Aid flow (current US$) in South Africa?
Ensure brevity in your answer.  1.62e+07. In the year 2012, what is the difference between the Aid flow (current US$) in Dominican Republic and Aid flow (current US$) in South Africa?
Your answer should be compact. -9.99e+06. What is the ratio of the Aid flow (current US$) in Europe(developing only) in 2006 to that in 2007?
Your answer should be very brief. 1.63. What is the ratio of the Aid flow (current US$) in Bolivia in 2006 to that in 2007?
Your answer should be compact. 0.75. What is the ratio of the Aid flow (current US$) of Dominican Republic in 2006 to that in 2007?
Your answer should be compact. 0.57. What is the ratio of the Aid flow (current US$) in South Africa in 2006 to that in 2007?
Give a very brief answer. 0.8. What is the ratio of the Aid flow (current US$) in Europe(developing only) in 2006 to that in 2008?
Provide a short and direct response. 2.23. What is the ratio of the Aid flow (current US$) in Bolivia in 2006 to that in 2008?
Provide a succinct answer. 0.79. What is the ratio of the Aid flow (current US$) in South Africa in 2006 to that in 2008?
Offer a terse response. 0.76. What is the ratio of the Aid flow (current US$) in Europe(developing only) in 2006 to that in 2009?
Give a very brief answer. 2.82. What is the ratio of the Aid flow (current US$) in Bolivia in 2006 to that in 2009?
Your response must be concise. 0.7. What is the ratio of the Aid flow (current US$) of Dominican Republic in 2006 to that in 2009?
Provide a succinct answer. 0.63. What is the ratio of the Aid flow (current US$) in South Africa in 2006 to that in 2009?
Make the answer very short. 0.86. What is the ratio of the Aid flow (current US$) of Europe(developing only) in 2006 to that in 2010?
Provide a succinct answer. 2.24. What is the ratio of the Aid flow (current US$) of Bolivia in 2006 to that in 2010?
Your response must be concise. 0.89. What is the ratio of the Aid flow (current US$) of Dominican Republic in 2006 to that in 2010?
Keep it short and to the point. 1.23. What is the ratio of the Aid flow (current US$) in South Africa in 2006 to that in 2010?
Keep it short and to the point. 0.68. What is the ratio of the Aid flow (current US$) in Europe(developing only) in 2006 to that in 2011?
Provide a short and direct response. 3.04. What is the ratio of the Aid flow (current US$) of Bolivia in 2006 to that in 2011?
Provide a succinct answer. 0.63. What is the ratio of the Aid flow (current US$) in Dominican Republic in 2006 to that in 2011?
Make the answer very short. 2.29. What is the ratio of the Aid flow (current US$) of South Africa in 2006 to that in 2011?
Give a very brief answer. 0.95. What is the ratio of the Aid flow (current US$) of Europe(developing only) in 2006 to that in 2012?
Make the answer very short. 1.19. What is the ratio of the Aid flow (current US$) of Bolivia in 2006 to that in 2012?
Keep it short and to the point. 0.61. What is the ratio of the Aid flow (current US$) of Dominican Republic in 2006 to that in 2012?
Keep it short and to the point. 0.93. What is the ratio of the Aid flow (current US$) in South Africa in 2006 to that in 2012?
Your answer should be compact. 0.95. What is the ratio of the Aid flow (current US$) in Europe(developing only) in 2007 to that in 2008?
Keep it short and to the point. 1.37. What is the ratio of the Aid flow (current US$) of Bolivia in 2007 to that in 2008?
Offer a very short reply. 1.06. What is the ratio of the Aid flow (current US$) of Dominican Republic in 2007 to that in 2008?
Provide a succinct answer. 1.77. What is the ratio of the Aid flow (current US$) in South Africa in 2007 to that in 2008?
Your answer should be very brief. 0.95. What is the ratio of the Aid flow (current US$) of Europe(developing only) in 2007 to that in 2009?
Your answer should be compact. 1.73. What is the ratio of the Aid flow (current US$) of Bolivia in 2007 to that in 2009?
Offer a terse response. 0.94. What is the ratio of the Aid flow (current US$) of Dominican Republic in 2007 to that in 2009?
Offer a terse response. 1.11. What is the ratio of the Aid flow (current US$) of South Africa in 2007 to that in 2009?
Offer a very short reply. 1.07. What is the ratio of the Aid flow (current US$) of Europe(developing only) in 2007 to that in 2010?
Offer a very short reply. 1.38. What is the ratio of the Aid flow (current US$) of Bolivia in 2007 to that in 2010?
Keep it short and to the point. 1.2. What is the ratio of the Aid flow (current US$) in Dominican Republic in 2007 to that in 2010?
Provide a short and direct response. 2.17. What is the ratio of the Aid flow (current US$) of South Africa in 2007 to that in 2010?
Provide a succinct answer. 0.85. What is the ratio of the Aid flow (current US$) of Europe(developing only) in 2007 to that in 2011?
Provide a succinct answer. 1.87. What is the ratio of the Aid flow (current US$) in Bolivia in 2007 to that in 2011?
Give a very brief answer. 0.84. What is the ratio of the Aid flow (current US$) of Dominican Republic in 2007 to that in 2011?
Make the answer very short. 4.04. What is the ratio of the Aid flow (current US$) of South Africa in 2007 to that in 2011?
Your response must be concise. 1.19. What is the ratio of the Aid flow (current US$) of Europe(developing only) in 2007 to that in 2012?
Offer a terse response. 0.73. What is the ratio of the Aid flow (current US$) of Bolivia in 2007 to that in 2012?
Provide a succinct answer. 0.81. What is the ratio of the Aid flow (current US$) of Dominican Republic in 2007 to that in 2012?
Offer a terse response. 1.64. What is the ratio of the Aid flow (current US$) of South Africa in 2007 to that in 2012?
Offer a terse response. 1.19. What is the ratio of the Aid flow (current US$) of Europe(developing only) in 2008 to that in 2009?
Keep it short and to the point. 1.27. What is the ratio of the Aid flow (current US$) in Bolivia in 2008 to that in 2009?
Your response must be concise. 0.88. What is the ratio of the Aid flow (current US$) in Dominican Republic in 2008 to that in 2009?
Provide a short and direct response. 0.62. What is the ratio of the Aid flow (current US$) in South Africa in 2008 to that in 2009?
Provide a short and direct response. 1.13. What is the ratio of the Aid flow (current US$) in Europe(developing only) in 2008 to that in 2010?
Offer a terse response. 1.01. What is the ratio of the Aid flow (current US$) in Bolivia in 2008 to that in 2010?
Offer a terse response. 1.13. What is the ratio of the Aid flow (current US$) of Dominican Republic in 2008 to that in 2010?
Keep it short and to the point. 1.22. What is the ratio of the Aid flow (current US$) of South Africa in 2008 to that in 2010?
Offer a very short reply. 0.89. What is the ratio of the Aid flow (current US$) of Europe(developing only) in 2008 to that in 2011?
Provide a succinct answer. 1.37. What is the ratio of the Aid flow (current US$) in Bolivia in 2008 to that in 2011?
Offer a terse response. 0.8. What is the ratio of the Aid flow (current US$) of Dominican Republic in 2008 to that in 2011?
Make the answer very short. 2.28. What is the ratio of the Aid flow (current US$) of South Africa in 2008 to that in 2011?
Your response must be concise. 1.24. What is the ratio of the Aid flow (current US$) of Europe(developing only) in 2008 to that in 2012?
Keep it short and to the point. 0.54. What is the ratio of the Aid flow (current US$) of Bolivia in 2008 to that in 2012?
Provide a succinct answer. 0.77. What is the ratio of the Aid flow (current US$) of Dominican Republic in 2008 to that in 2012?
Give a very brief answer. 0.93. What is the ratio of the Aid flow (current US$) of South Africa in 2008 to that in 2012?
Offer a very short reply. 1.25. What is the ratio of the Aid flow (current US$) in Europe(developing only) in 2009 to that in 2010?
Make the answer very short. 0.79. What is the ratio of the Aid flow (current US$) of Bolivia in 2009 to that in 2010?
Provide a short and direct response. 1.28. What is the ratio of the Aid flow (current US$) in Dominican Republic in 2009 to that in 2010?
Keep it short and to the point. 1.96. What is the ratio of the Aid flow (current US$) in South Africa in 2009 to that in 2010?
Offer a very short reply. 0.79. What is the ratio of the Aid flow (current US$) of Europe(developing only) in 2009 to that in 2011?
Provide a short and direct response. 1.08. What is the ratio of the Aid flow (current US$) of Bolivia in 2009 to that in 2011?
Offer a terse response. 0.9. What is the ratio of the Aid flow (current US$) of Dominican Republic in 2009 to that in 2011?
Offer a terse response. 3.65. What is the ratio of the Aid flow (current US$) in South Africa in 2009 to that in 2011?
Ensure brevity in your answer.  1.1. What is the ratio of the Aid flow (current US$) in Europe(developing only) in 2009 to that in 2012?
Offer a very short reply. 0.42. What is the ratio of the Aid flow (current US$) in Bolivia in 2009 to that in 2012?
Ensure brevity in your answer.  0.87. What is the ratio of the Aid flow (current US$) in Dominican Republic in 2009 to that in 2012?
Your answer should be very brief. 1.49. What is the ratio of the Aid flow (current US$) of South Africa in 2009 to that in 2012?
Offer a very short reply. 1.1. What is the ratio of the Aid flow (current US$) of Europe(developing only) in 2010 to that in 2011?
Make the answer very short. 1.36. What is the ratio of the Aid flow (current US$) in Bolivia in 2010 to that in 2011?
Your response must be concise. 0.7. What is the ratio of the Aid flow (current US$) in Dominican Republic in 2010 to that in 2011?
Keep it short and to the point. 1.86. What is the ratio of the Aid flow (current US$) in South Africa in 2010 to that in 2011?
Your answer should be compact. 1.4. What is the ratio of the Aid flow (current US$) in Europe(developing only) in 2010 to that in 2012?
Provide a short and direct response. 0.53. What is the ratio of the Aid flow (current US$) of Bolivia in 2010 to that in 2012?
Your response must be concise. 0.68. What is the ratio of the Aid flow (current US$) in Dominican Republic in 2010 to that in 2012?
Ensure brevity in your answer.  0.76. What is the ratio of the Aid flow (current US$) in South Africa in 2010 to that in 2012?
Your answer should be very brief. 1.4. What is the ratio of the Aid flow (current US$) in Europe(developing only) in 2011 to that in 2012?
Make the answer very short. 0.39. What is the ratio of the Aid flow (current US$) in Bolivia in 2011 to that in 2012?
Ensure brevity in your answer.  0.96. What is the ratio of the Aid flow (current US$) in Dominican Republic in 2011 to that in 2012?
Provide a succinct answer. 0.41. What is the difference between the highest and the second highest Aid flow (current US$) in Europe(developing only)?
Offer a very short reply. 1.35e+07. What is the difference between the highest and the second highest Aid flow (current US$) of Bolivia?
Your response must be concise. 9.80e+05. What is the difference between the highest and the second highest Aid flow (current US$) in South Africa?
Your answer should be very brief. 1.83e+06. What is the difference between the highest and the lowest Aid flow (current US$) of Europe(developing only)?
Offer a very short reply. 5.56e+07. What is the difference between the highest and the lowest Aid flow (current US$) of Bolivia?
Your answer should be compact. 1.10e+07. What is the difference between the highest and the lowest Aid flow (current US$) of Dominican Republic?
Provide a succinct answer. 2.19e+06. What is the difference between the highest and the lowest Aid flow (current US$) in South Africa?
Provide a succinct answer. 5.34e+06. 